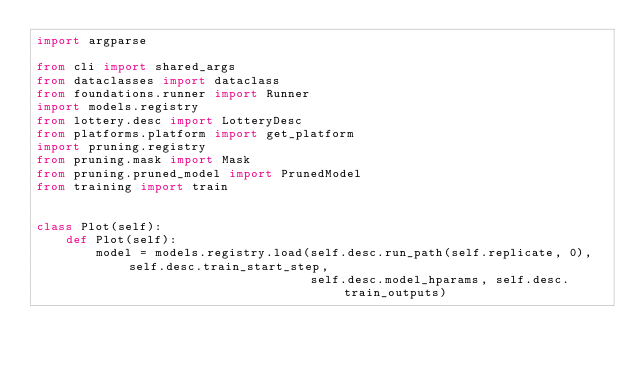<code> <loc_0><loc_0><loc_500><loc_500><_Python_>import argparse

from cli import shared_args
from dataclasses import dataclass
from foundations.runner import Runner
import models.registry
from lottery.desc import LotteryDesc
from platforms.platform import get_platform
import pruning.registry
from pruning.mask import Mask
from pruning.pruned_model import PrunedModel
from training import train


class Plot(self):
    def Plot(self):
        model = models.registry.load(self.desc.run_path(self.replicate, 0), self.desc.train_start_step,
                                     self.desc.model_hparams, self.desc.train_outputs)</code> 